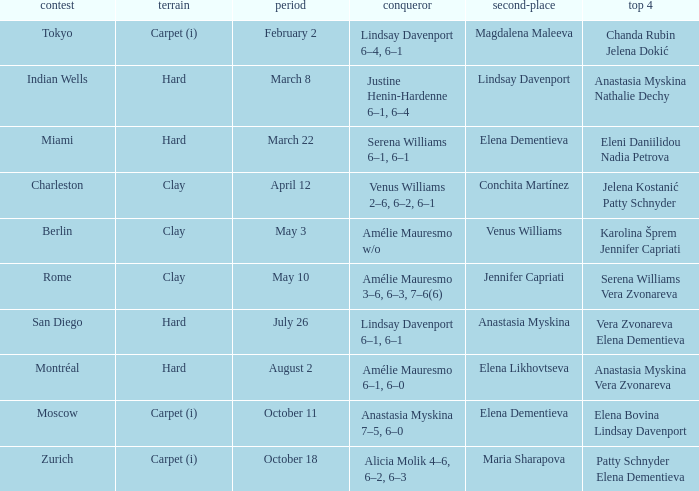Who were the semifinalists in the Rome tournament? Serena Williams Vera Zvonareva. 